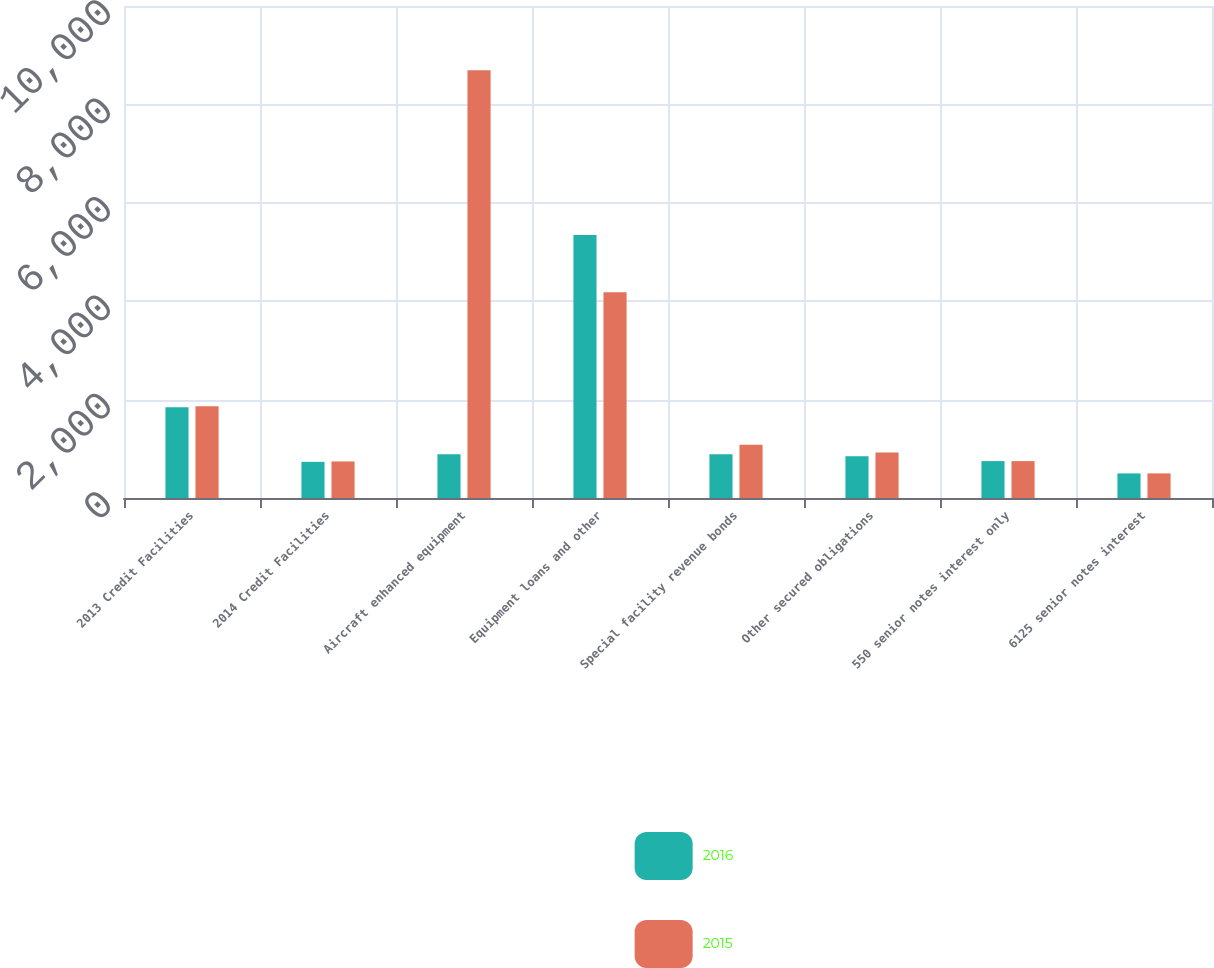Convert chart. <chart><loc_0><loc_0><loc_500><loc_500><stacked_bar_chart><ecel><fcel>2013 Credit Facilities<fcel>2014 Credit Facilities<fcel>Aircraft enhanced equipment<fcel>Equipment loans and other<fcel>Special facility revenue bonds<fcel>Other secured obligations<fcel>550 senior notes interest only<fcel>6125 senior notes interest<nl><fcel>2016<fcel>1843<fcel>735<fcel>891<fcel>5343<fcel>891<fcel>849<fcel>750<fcel>500<nl><fcel>2015<fcel>1867<fcel>743<fcel>8693<fcel>4183<fcel>1080<fcel>923<fcel>750<fcel>500<nl></chart> 